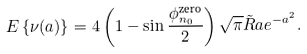<formula> <loc_0><loc_0><loc_500><loc_500>E \left \{ \nu ( a ) \right \} = 4 \left ( 1 - \sin \frac { \phi ^ { \text {zero} } _ { n _ { 0 } } } { 2 } \right ) \sqrt { \pi } \tilde { R } a e ^ { - a ^ { 2 } } .</formula> 